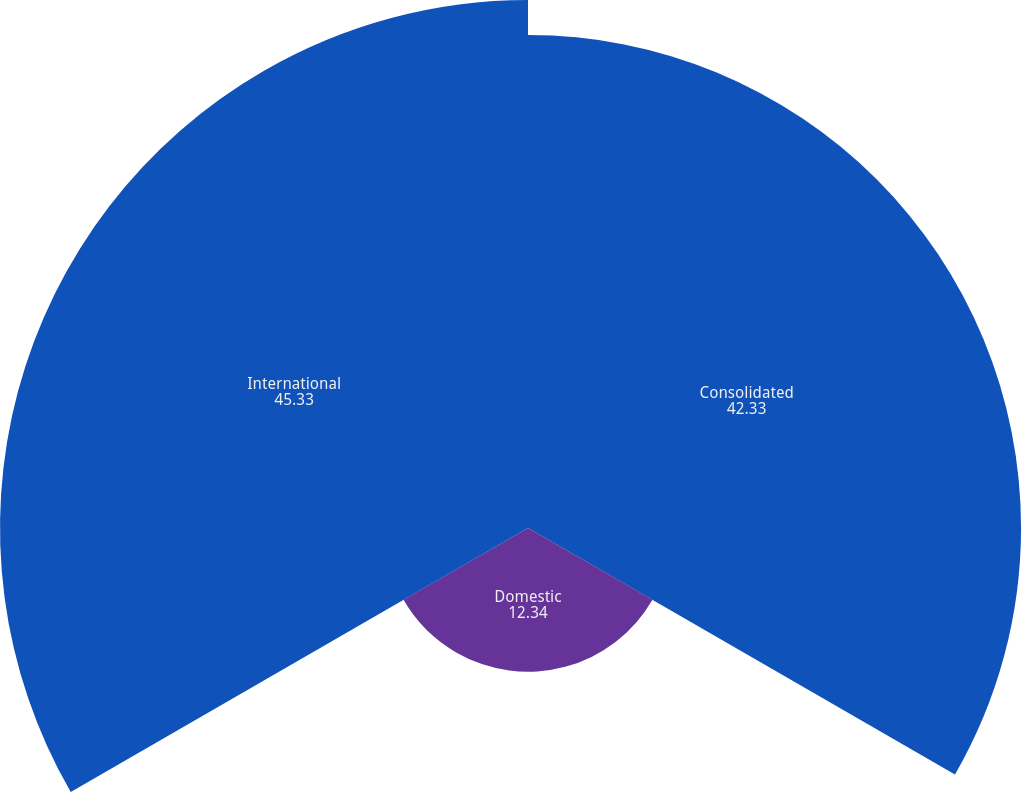Convert chart to OTSL. <chart><loc_0><loc_0><loc_500><loc_500><pie_chart><fcel>Consolidated<fcel>Domestic<fcel>International<nl><fcel>42.33%<fcel>12.34%<fcel>45.33%<nl></chart> 